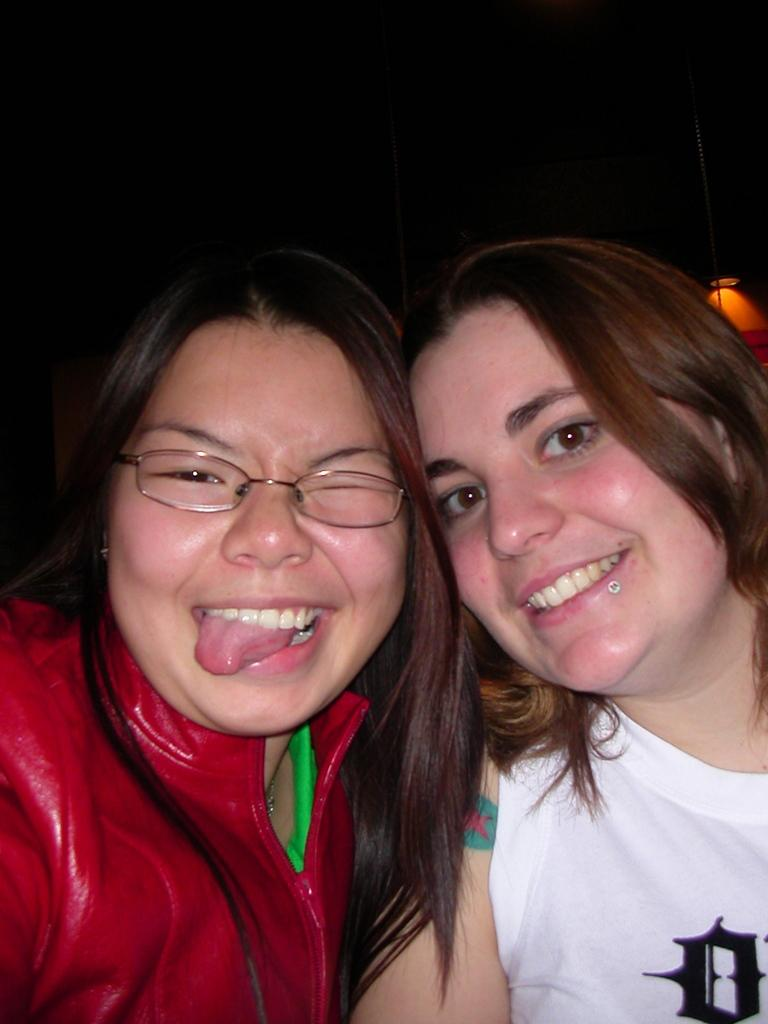How many people are in the image? There are two women in the image. What is the facial expression of the women in the image? The women are smiling. What type of heart is visible in the image? There is no heart visible in the image; it only features two women who are smiling. 